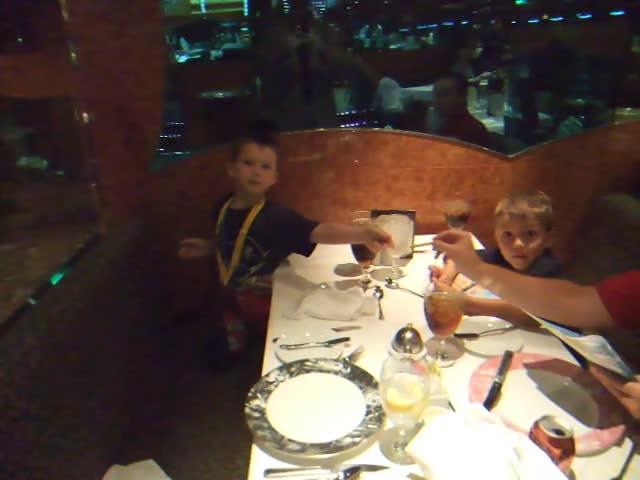What color is the lanyard string worn around the little boy's neck?

Choices:
A) yellow
B) green
C) blue
D) black yellow 